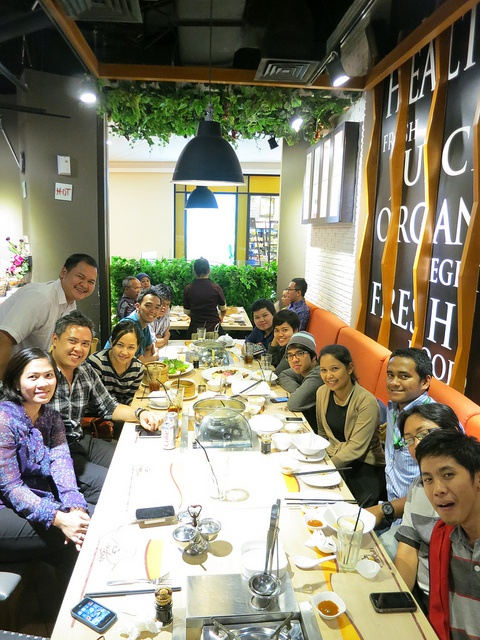Describe the objects in this image and their specific colors. I can see dining table in black, white, khaki, darkgray, and tan tones, people in black, lavender, violet, and gray tones, people in black, maroon, and brown tones, people in black, darkgray, and gray tones, and people in black, tan, and olive tones in this image. 